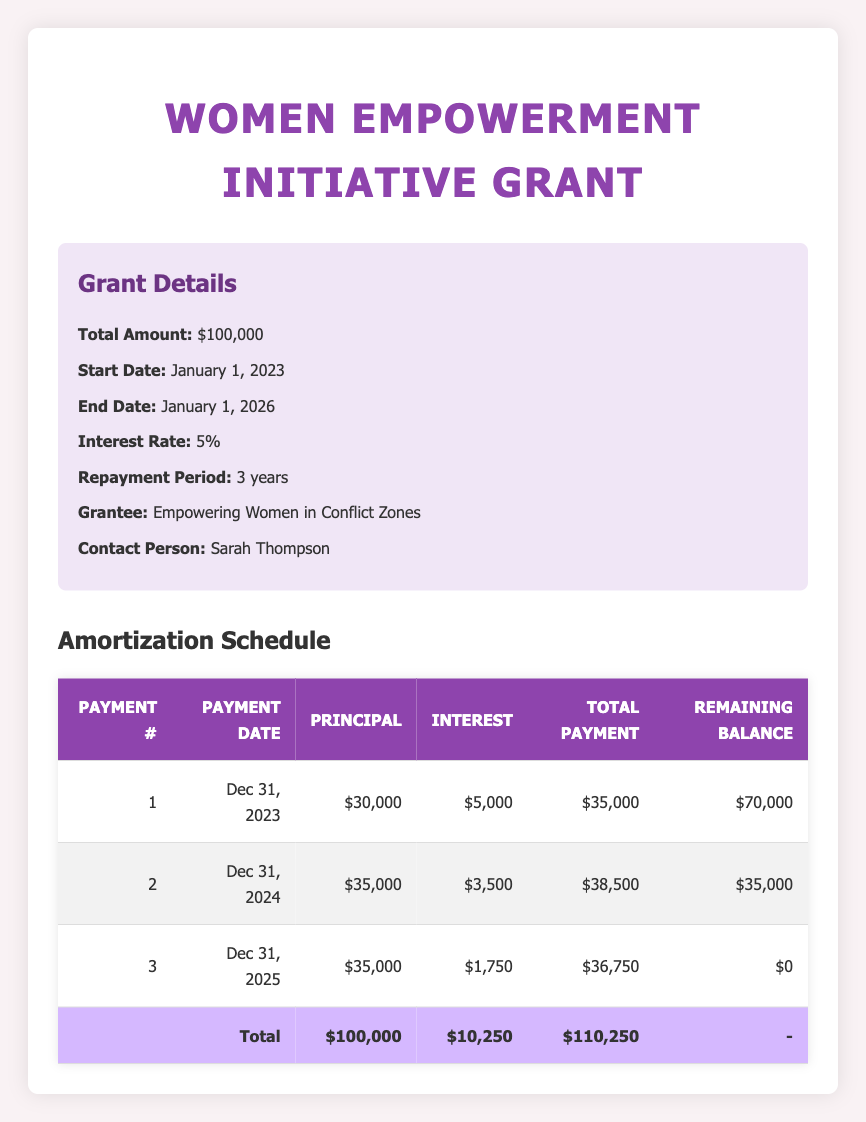What is the total amount granted for the Women Empowerment Initiative? The total amount granted for the Women Empowerment Initiative is listed directly in the grant details section of the table. It states '$100,000'.
Answer: 100000 When is the final payment due for the grant? The final payment is due on December 31, 2025, as indicated in the payment schedule under the "Payment Date" column for the last payment number.
Answer: December 31, 2025 How much was the second principal payment? The second principal payment is specifically recorded in the table under the column "Principal" for the second payment number, which is '$35,000'.
Answer: 35000 What is the total remaining balance after the first payment? To find the remaining balance after the first payment, we look at the "Remaining Balance" column for payment number 1, which shows '$70,000'.
Answer: 70000 Is the total payment for the third payment greater than the first payment? The total payment for the third payment is '$36,750', and for the first payment, it is '$35,000'. Since '$36,750' is greater than '$35,000', the statement is true.
Answer: Yes What is the sum of all principal payments made over the three payment periods? To find the total principal payments, we add together the principal amounts for the three payments: $30,000 + $35,000 + $35,000 = $100,000.
Answer: 100000 How much total interest was paid by the end of the repayment period? The total interest paid can be calculated by summing the "Interest" amounts from all payment periods: $5,000 + $3,500 + $1,750 = $10,250. This value can also be found in the total row under the total column for interest.
Answer: 10250 Do all principal payments decrease from the first to the last payment? In examining the principal payments: the first is $30,000, the second is $35,000, and the third is also $35,000. The second is greater than the first, making the statement false.
Answer: No What was the average total payment made across all three payments? To find the average total payment, we sum the total payments: $35,000 + $38,500 + $36,750 = $110,250, and then divide by the number of payments, which is 3. Thus, $110,250 / 3 = $36,750.
Answer: 36750 